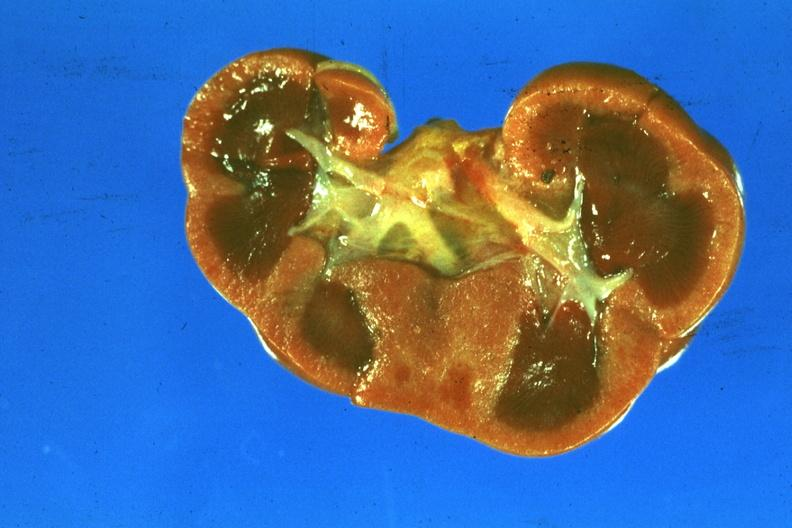what is present?
Answer the question using a single word or phrase. Kidney 